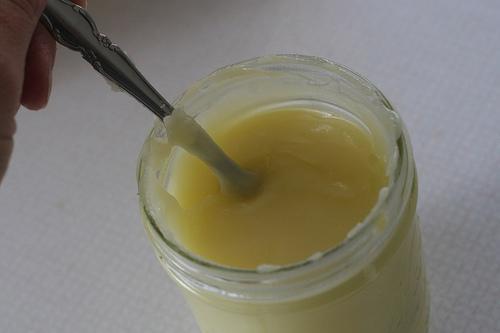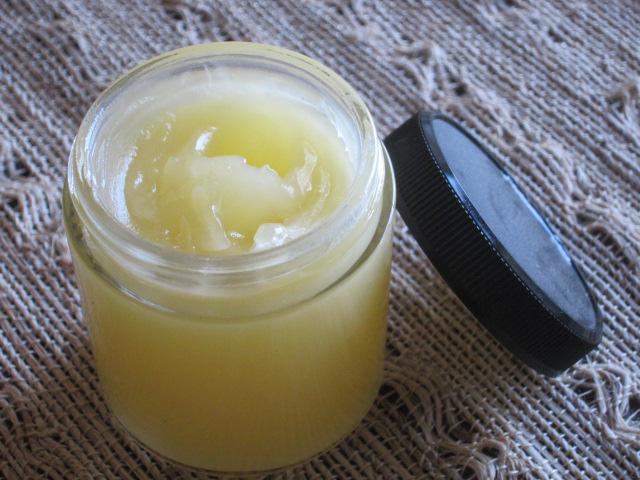The first image is the image on the left, the second image is the image on the right. Analyze the images presented: Is the assertion "There is a glass jar filled with a light yellow substance in each of the images." valid? Answer yes or no. Yes. 